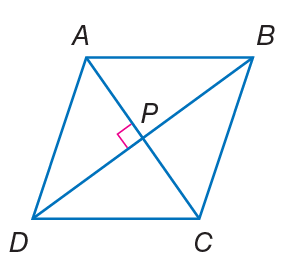Answer the mathemtical geometry problem and directly provide the correct option letter.
Question: Quadrilateral A B C D is a rhombus. If A P = 3 x - 1 and P C = x + 9, find A C.
Choices: A: 17 B: 28 C: 50 D: 76 B 